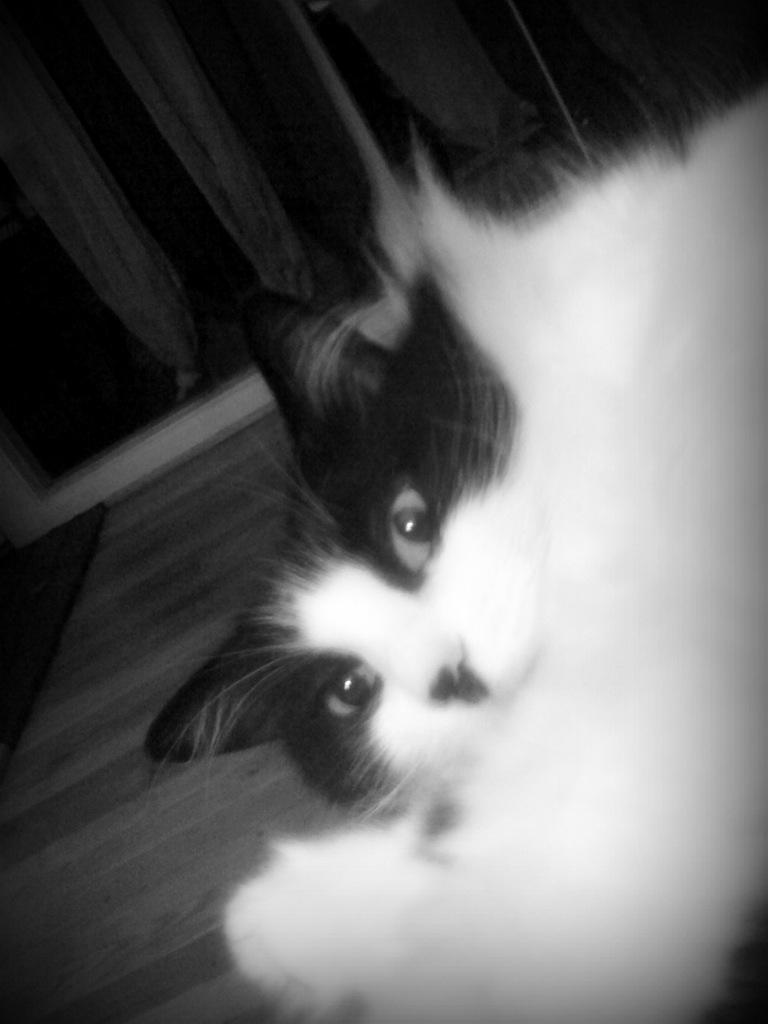What is the color scheme of the image? The image is black and white. What animal can be seen in the image? There is a cat in the image. Where is the cat located in the image? The cat is on the right side of the floor. What is present on the wall in the image? The wall has curtains. What type of paper is the cat reading in the image? There is no paper present in the image, and the cat is not shown reading anything. 